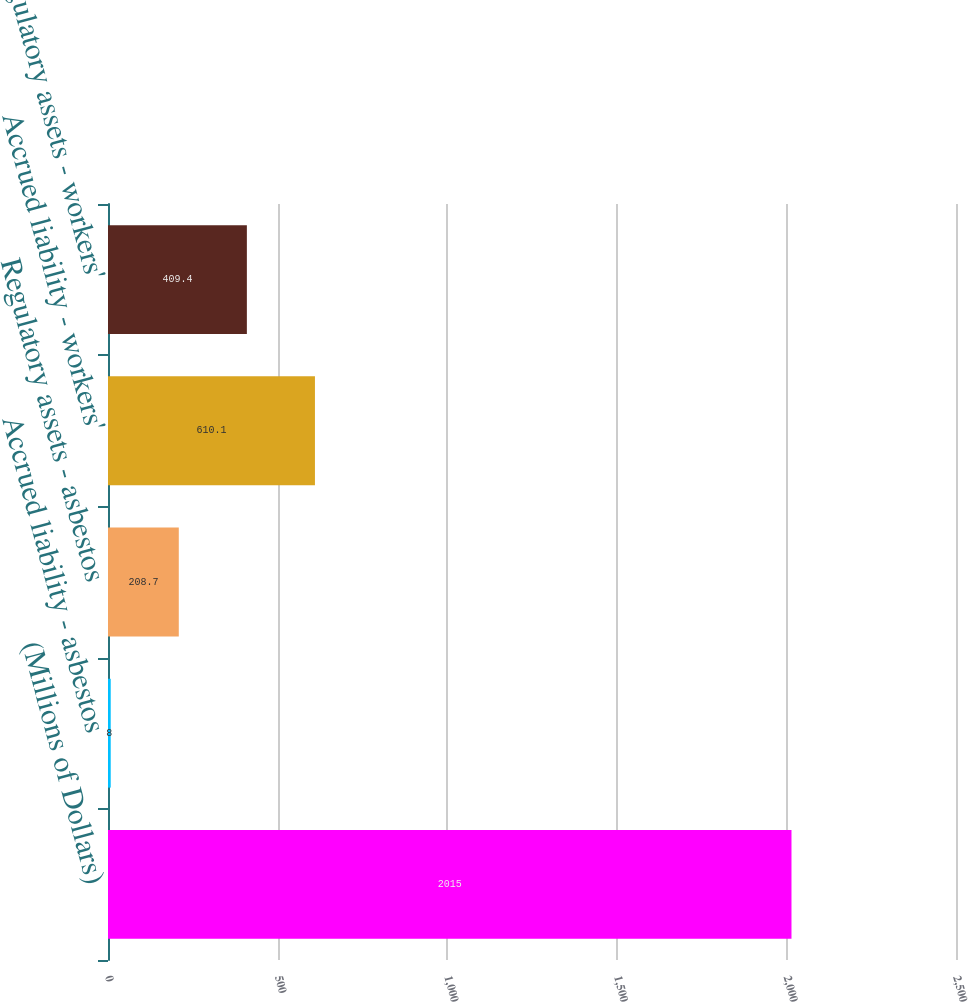<chart> <loc_0><loc_0><loc_500><loc_500><bar_chart><fcel>(Millions of Dollars)<fcel>Accrued liability - asbestos<fcel>Regulatory assets - asbestos<fcel>Accrued liability - workers'<fcel>Regulatory assets - workers'<nl><fcel>2015<fcel>8<fcel>208.7<fcel>610.1<fcel>409.4<nl></chart> 